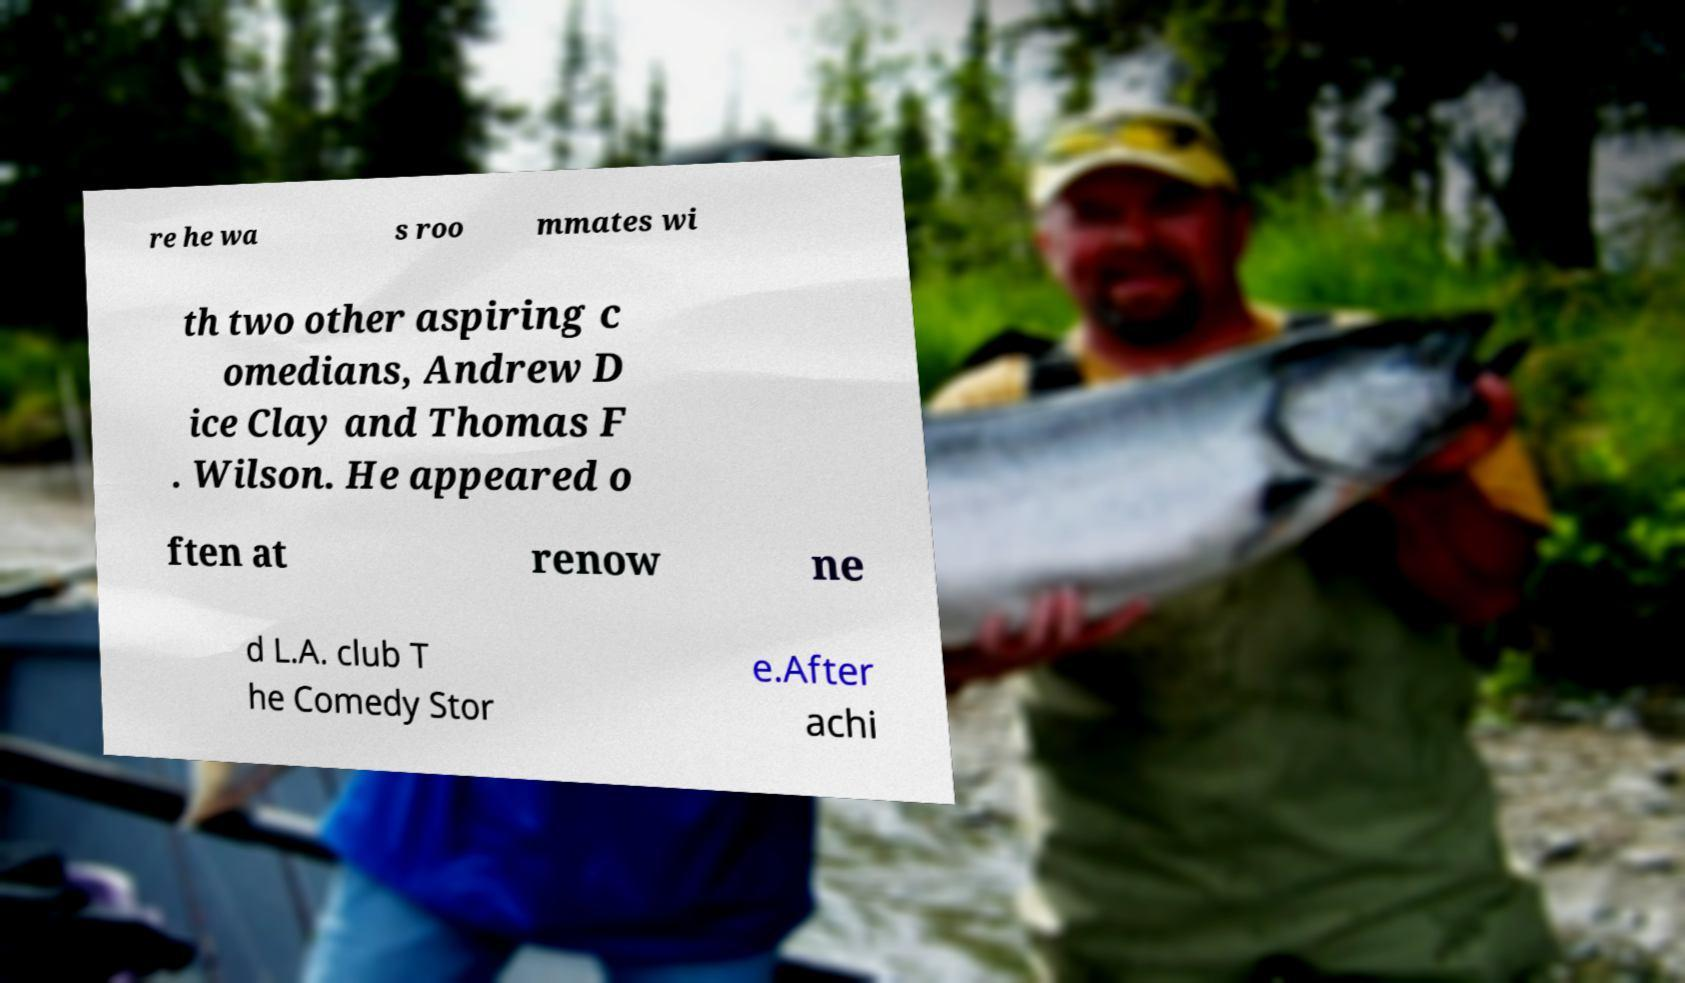Could you assist in decoding the text presented in this image and type it out clearly? re he wa s roo mmates wi th two other aspiring c omedians, Andrew D ice Clay and Thomas F . Wilson. He appeared o ften at renow ne d L.A. club T he Comedy Stor e.After achi 